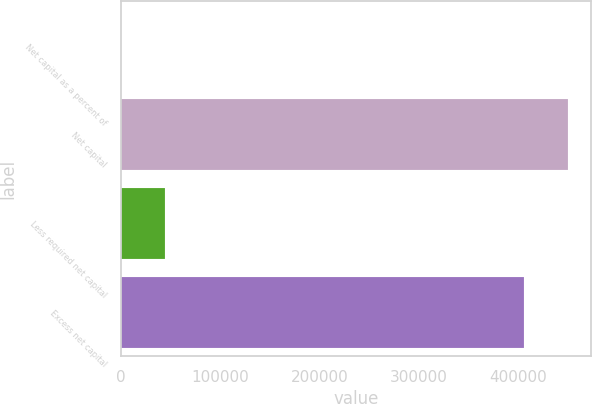<chart> <loc_0><loc_0><loc_500><loc_500><bar_chart><fcel>Net capital as a percent of<fcel>Net capital<fcel>Less required net capital<fcel>Excess net capital<nl><fcel>24.14<fcel>450456<fcel>44308.3<fcel>406172<nl></chart> 